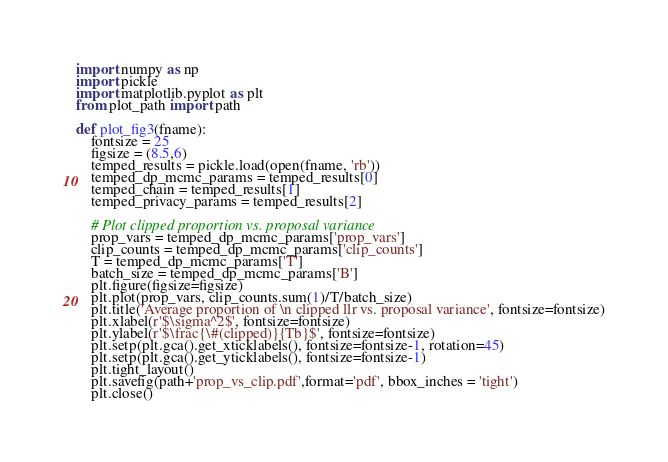Convert code to text. <code><loc_0><loc_0><loc_500><loc_500><_Python_>import numpy as np
import pickle
import matplotlib.pyplot as plt
from plot_path import path

def plot_fig3(fname):
	fontsize = 25
	figsize = (8.5,6)
	temped_results = pickle.load(open(fname, 'rb'))
	temped_dp_mcmc_params = temped_results[0]
	temped_chain = temped_results[1]
	temped_privacy_params = temped_results[2]

	# Plot clipped proportion vs. proposal variance
	prop_vars = temped_dp_mcmc_params['prop_vars']
	clip_counts = temped_dp_mcmc_params['clip_counts']
	T = temped_dp_mcmc_params['T']
	batch_size = temped_dp_mcmc_params['B']
	plt.figure(figsize=figsize)
	plt.plot(prop_vars, clip_counts.sum(1)/T/batch_size)
	plt.title('Average proportion of \n clipped llr vs. proposal variance', fontsize=fontsize)
	plt.xlabel(r'$\sigma^2$', fontsize=fontsize)
	plt.ylabel(r'$\frac{\#(clipped)}{Tb}$', fontsize=fontsize)
	plt.setp(plt.gca().get_xticklabels(), fontsize=fontsize-1, rotation=45)
	plt.setp(plt.gca().get_yticklabels(), fontsize=fontsize-1)
	plt.tight_layout()
	plt.savefig(path+'prop_vs_clip.pdf',format='pdf', bbox_inches = 'tight')
	plt.close()
</code> 